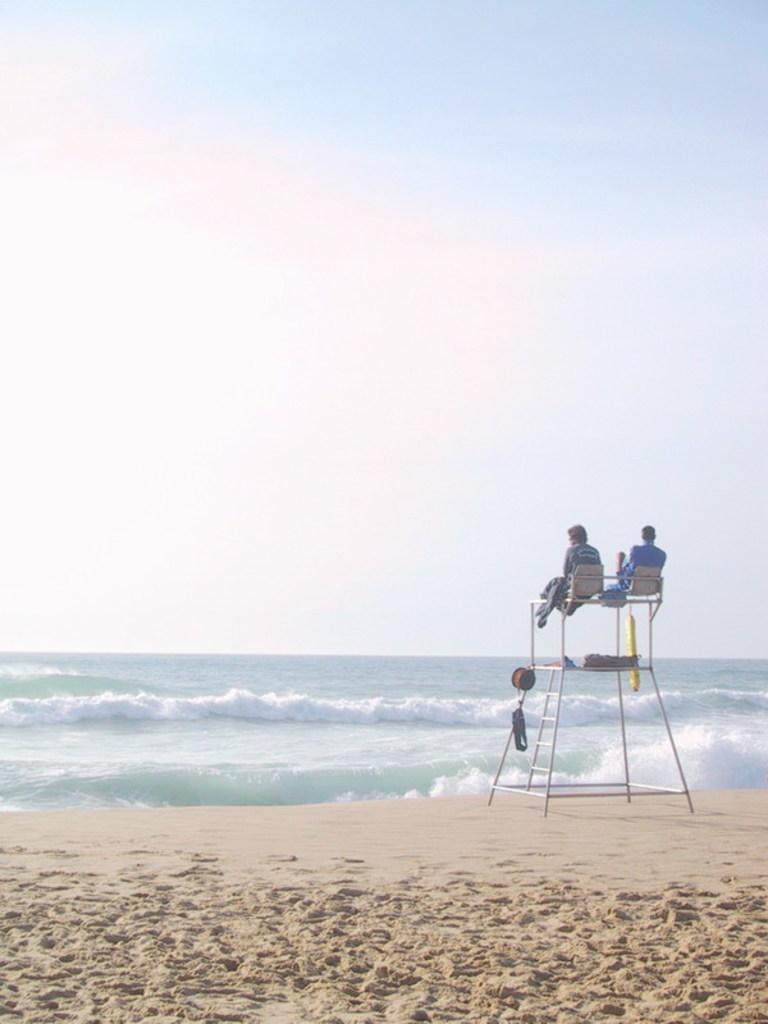Describe this image in one or two sentences. In this picture I can observe two members sitting on the stand in the beach. In the background there is an ocean and a sky. 